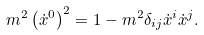Convert formula to latex. <formula><loc_0><loc_0><loc_500><loc_500>m ^ { 2 } \left ( \dot { x } ^ { 0 } \right ) ^ { 2 } = 1 - m ^ { 2 } \delta _ { i j } \dot { x } ^ { i } \dot { x } ^ { j } .</formula> 